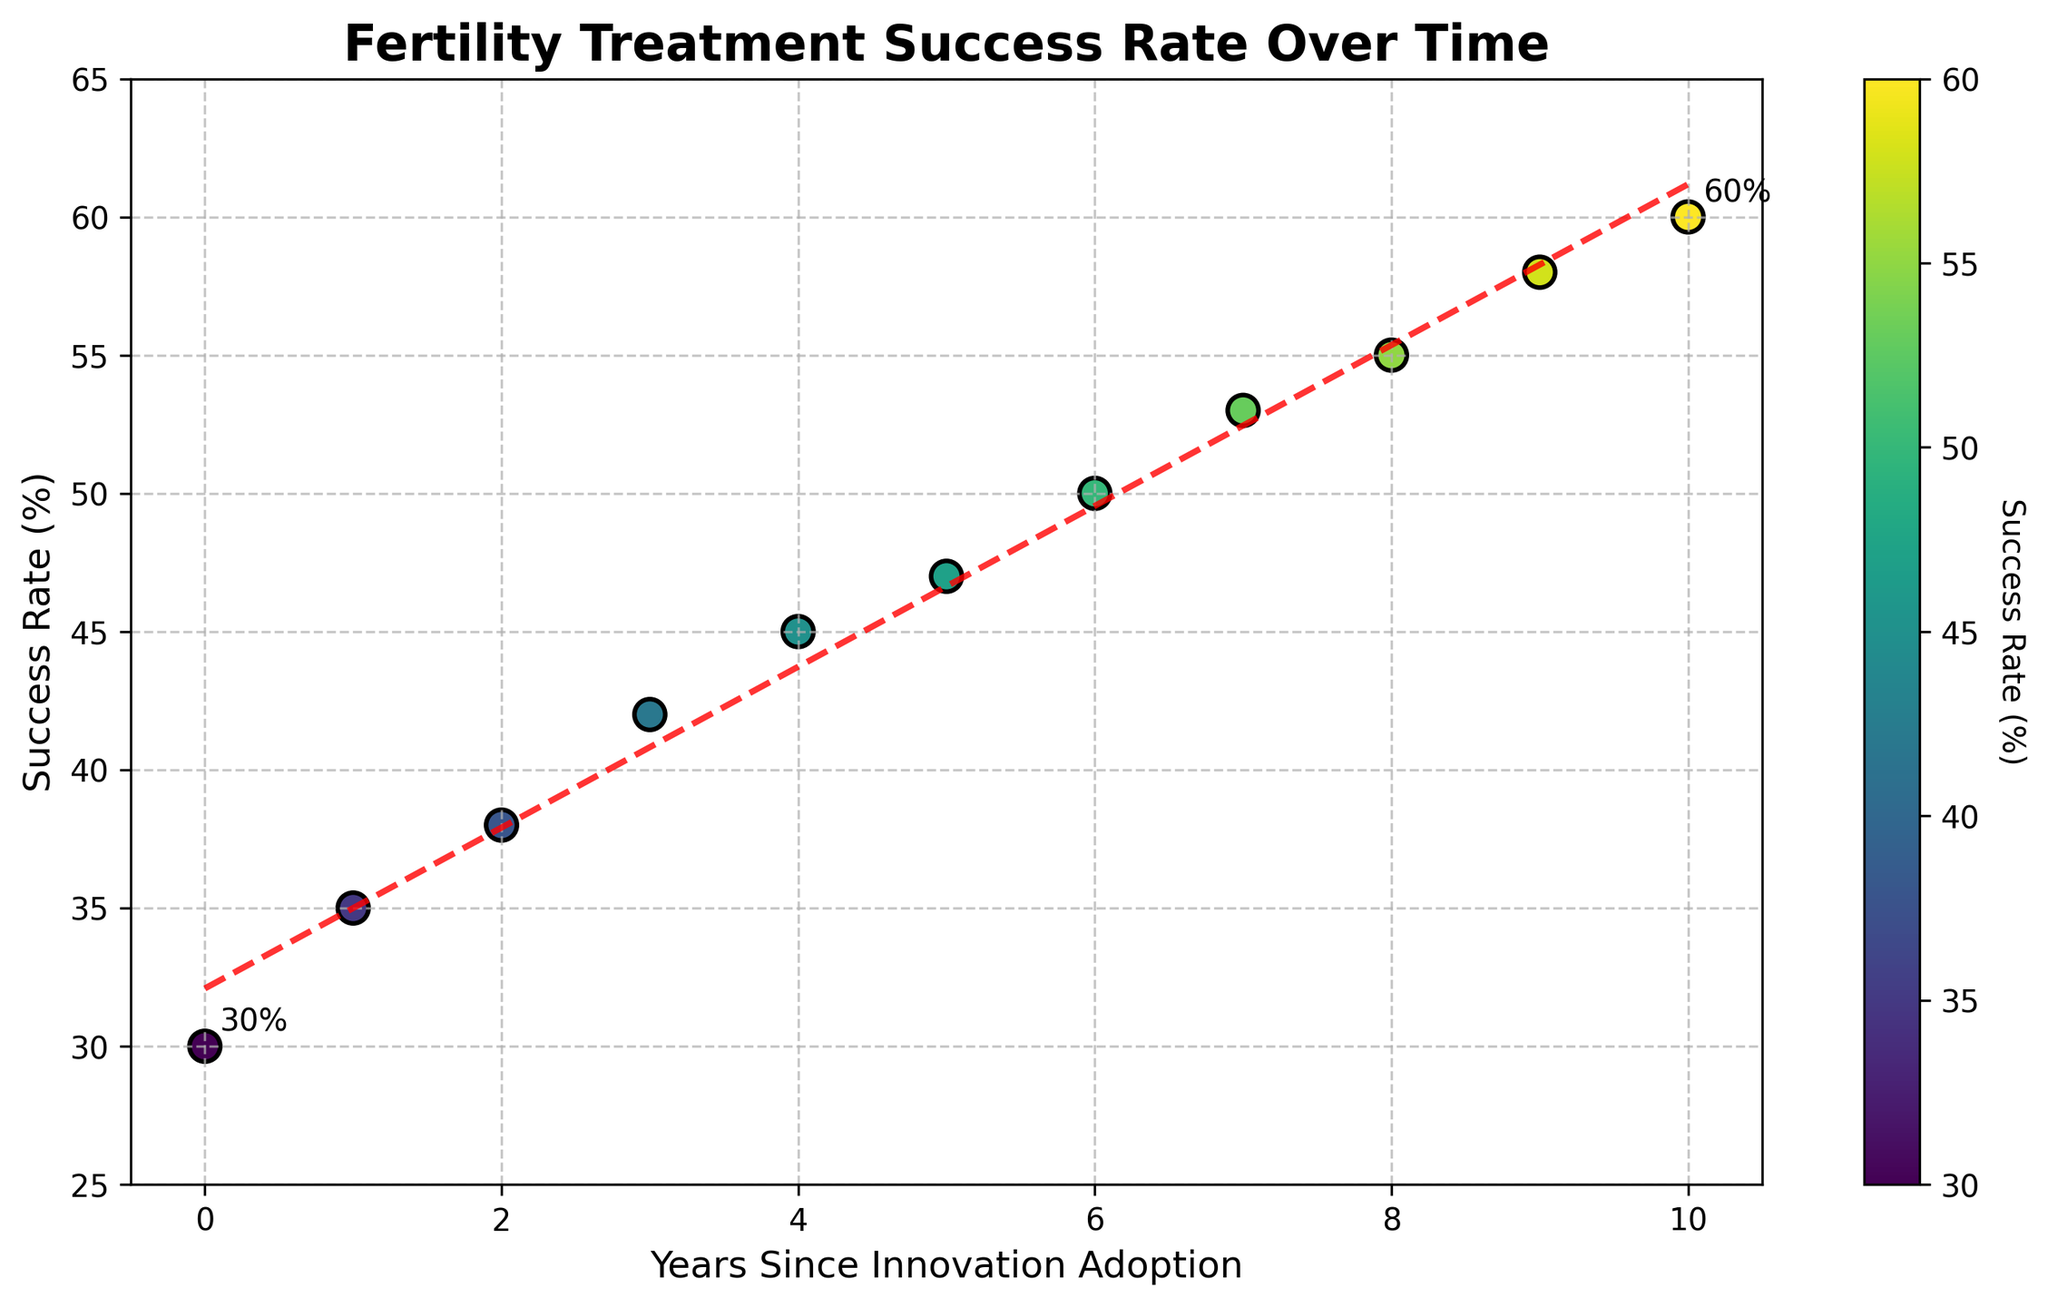What's the title of the plot? The title is given at the top center of the plot in large, bold font.
Answer: Fertility Treatment Success Rate Over Time What is the success rate at year 7? Locate the data point for year 7 on the x-axis and read the corresponding value on the y-axis.
Answer: 53% Which year shows the highest success rate? Identify the highest point on the y-axis and trace it back to the corresponding year on the x-axis.
Answer: Year 10 What is the general trend shown in the plot? Observe the overall direction of the scatter points and the trend line connecting them. The success rate generally increases over time.
Answer: Increasing trend How much did the success rate increase from year 4 to year 9? Calculate the difference between the success rate at year 9 and year 4 by subtracting the value at year 4 from the value at year 9. (58% - 45%)
Answer: 13% How many data points are represented in the scatter plot? Count each of the individual data points plotted on the scatter plot.
Answer: 11 What is the success rate at the start of the period (year 0)? Locate the data point for year 0 on the x-axis and read the corresponding value on the y-axis.
Answer: 30% What color corresponds to the highest success rates according to the colorbar? Check the colorbar on the side of the plot and identify the color at the top end.
Answer: Bright yellow/green Does the plot show a linear or non-linear relationship between years since innovation and success rate? Examine the overall pattern and the trend line. The trend line is almost straight, indicating a linear relationship.
Answer: Linear relationship What is the approximate equation of the trend line? The equation of the trend line can be estimated based on the given polyfit function used in the code. For a simple linear regression, the equation is generally in the form y = mx + c, where m is the slope and c is the intercept. From the given data, the trend line equation is approximately y = 2.93x + 29.09.
Answer: y = 2.93x + 29.09 